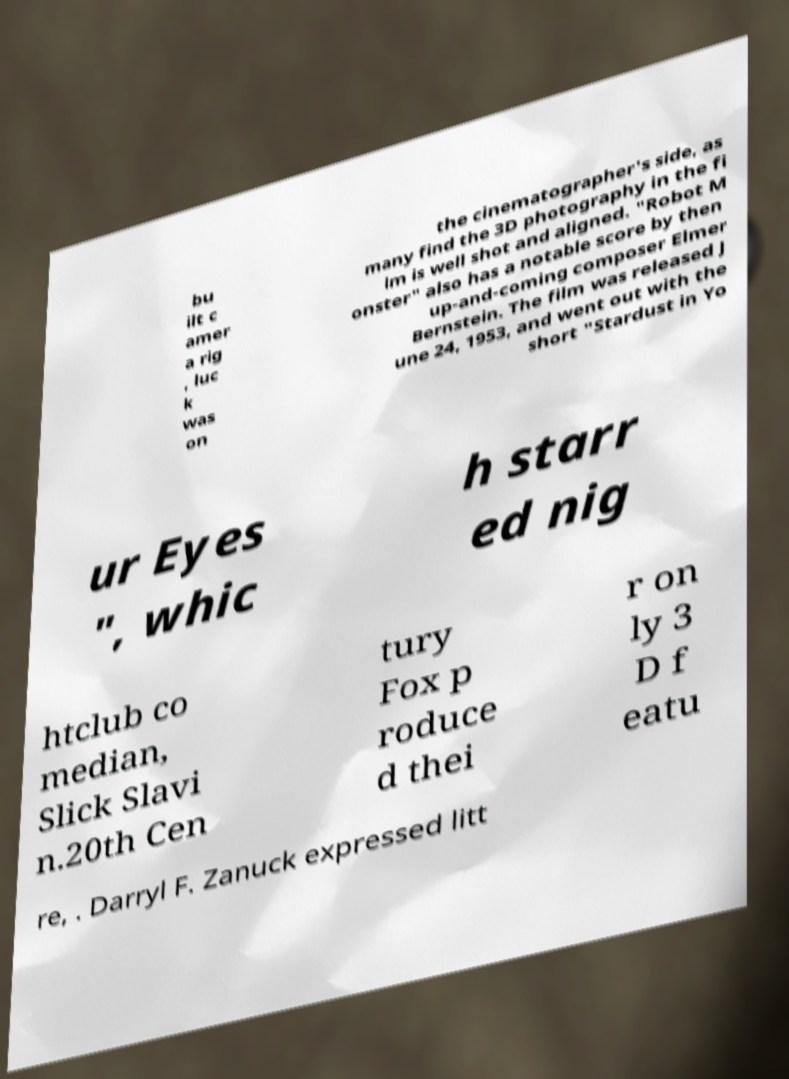Please read and relay the text visible in this image. What does it say? bu ilt c amer a rig , luc k was on the cinematographer's side, as many find the 3D photography in the fi lm is well shot and aligned. "Robot M onster" also has a notable score by then up-and-coming composer Elmer Bernstein. The film was released J une 24, 1953, and went out with the short "Stardust in Yo ur Eyes ", whic h starr ed nig htclub co median, Slick Slavi n.20th Cen tury Fox p roduce d thei r on ly 3 D f eatu re, . Darryl F. Zanuck expressed litt 